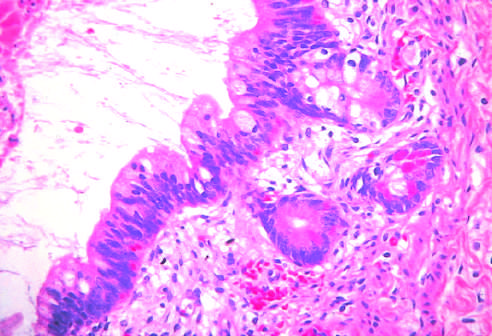do testicular teratomas contain mature cells from endodermal, mesodermal, and ectodermal lines?
Answer the question using a single word or phrase. Yes 